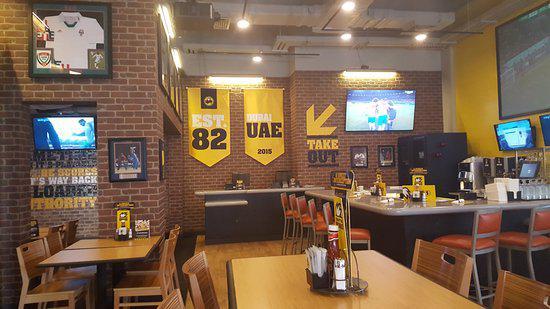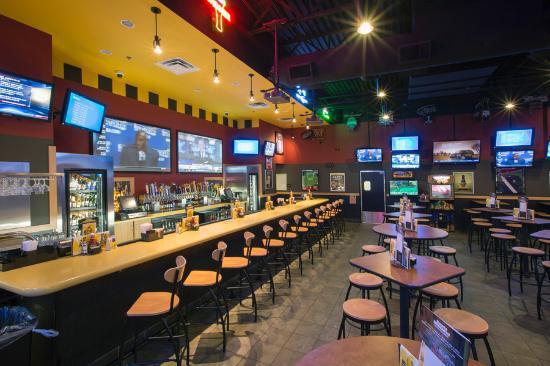The first image is the image on the left, the second image is the image on the right. Given the left and right images, does the statement "One bar area has a yellow ceiling and stools with backs at the bar." hold true? Answer yes or no. Yes. The first image is the image on the left, the second image is the image on the right. Evaluate the accuracy of this statement regarding the images: "A yellow wall can be seen in the background of the left image.". Is it true? Answer yes or no. Yes. 